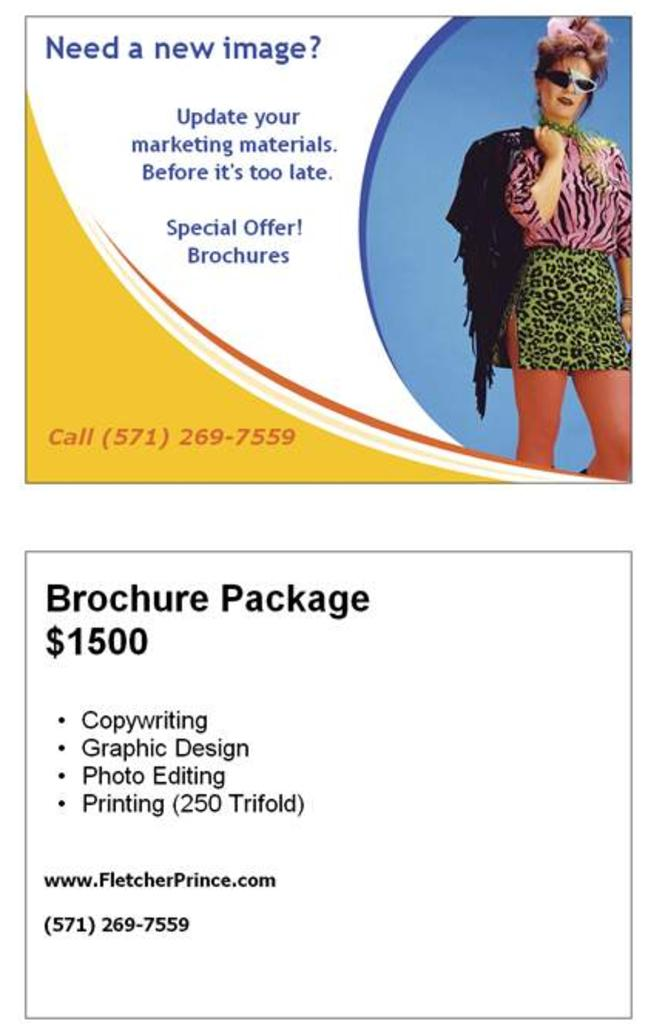What type of visual content is depicted in the image? The image is a poster. Who or what is featured in the poster? There is a woman in the image. What is the woman holding in the image? The woman is holding a jacket. What is the woman's posture in the image? The woman is standing. What type of development is taking place in the image? There is no development taking place in the image; it features a woman holding a jacket. Can you see any fairies in the image? There are no fairies present in the image. 